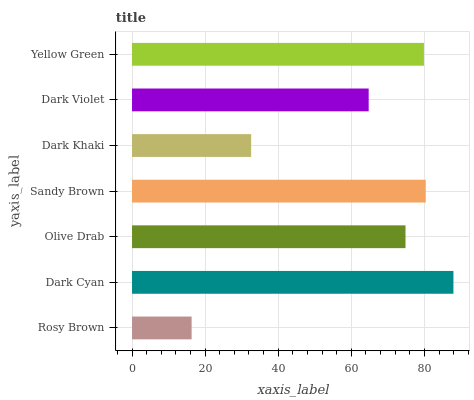Is Rosy Brown the minimum?
Answer yes or no. Yes. Is Dark Cyan the maximum?
Answer yes or no. Yes. Is Olive Drab the minimum?
Answer yes or no. No. Is Olive Drab the maximum?
Answer yes or no. No. Is Dark Cyan greater than Olive Drab?
Answer yes or no. Yes. Is Olive Drab less than Dark Cyan?
Answer yes or no. Yes. Is Olive Drab greater than Dark Cyan?
Answer yes or no. No. Is Dark Cyan less than Olive Drab?
Answer yes or no. No. Is Olive Drab the high median?
Answer yes or no. Yes. Is Olive Drab the low median?
Answer yes or no. Yes. Is Dark Violet the high median?
Answer yes or no. No. Is Dark Khaki the low median?
Answer yes or no. No. 